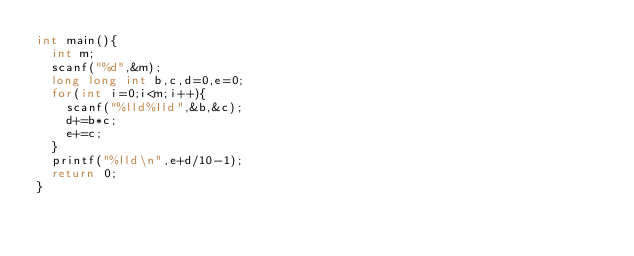<code> <loc_0><loc_0><loc_500><loc_500><_C_>int main(){
  int m;
  scanf("%d",&m);
  long long int b,c,d=0,e=0;
  for(int i=0;i<m;i++){
    scanf("%lld%lld",&b,&c);
    d+=b*c;
    e+=c;
  }
  printf("%lld\n",e+d/10-1);
  return 0;
}</code> 